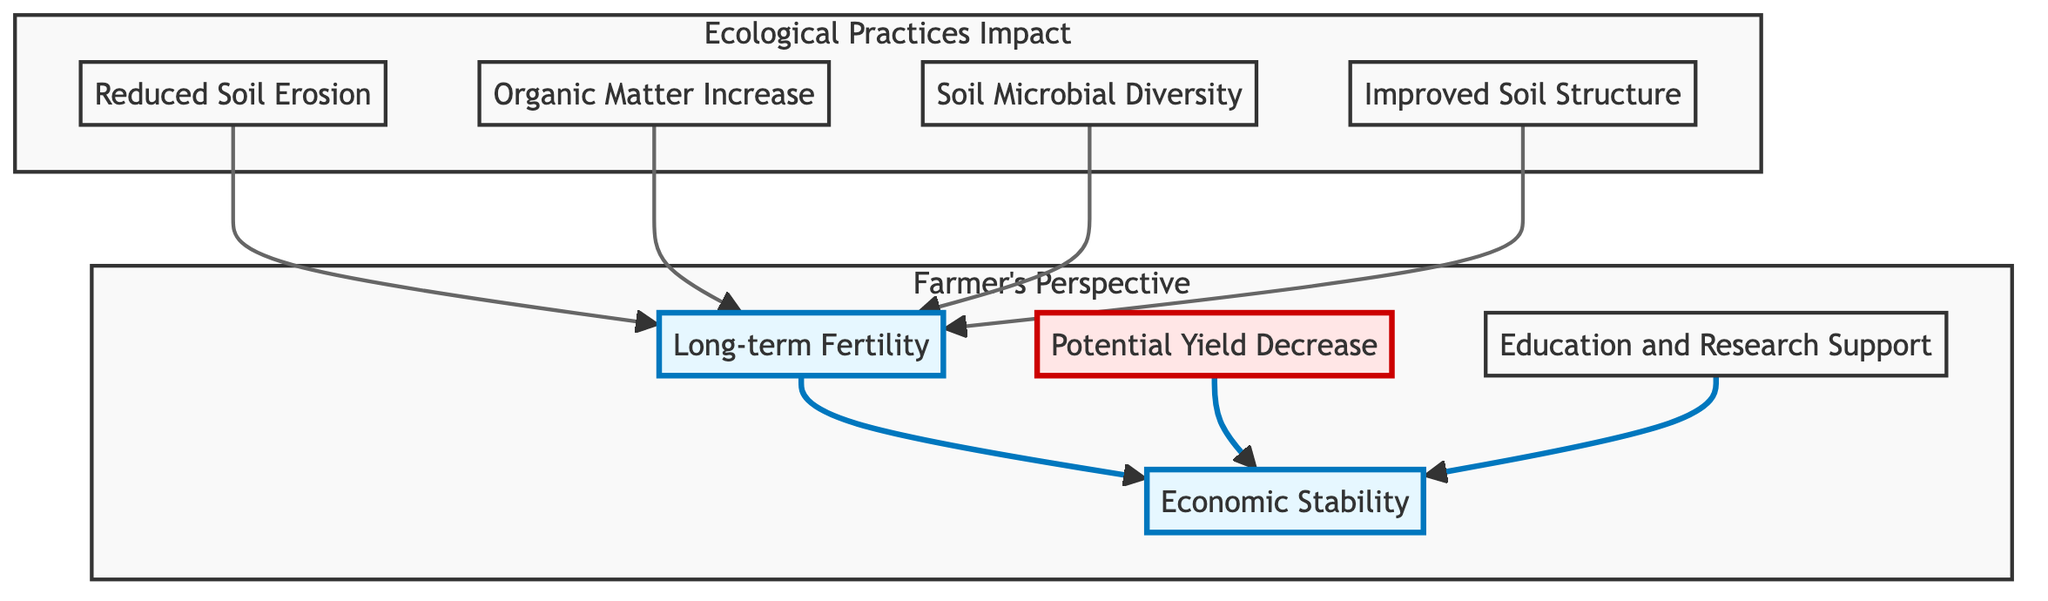What is the first node listed in the diagram? The first node listed in the diagram is "Reduced Soil Erosion". This can be identified as it is the first element in the list of nodes appearing in the flowchart.
Answer: Reduced Soil Erosion How many nodes are shown in the diagram? The diagram contains a total of 8 nodes, which can be counted by observing the distinct elements represented in the flowchart.
Answer: 8 What impact do improved soil structure practices have on long-term fertility? Improved soil structure enhances long-term fertility, as indicated by the arrows connecting "Improved Soil Structure" to "Long-term Fertility", showing that practices contribute positively to fertility over time.
Answer: Positive impact What node is directly linked to both "Long-term Fertility" and "Economic Stability"? "Long-term Fertility" is directly linked to "Economic Stability". The diagram shows a direct connection between these two nodes, indicating that fertility contributes to economic outcomes.
Answer: Long-term Fertility What is the potential downside mentioned in the diagram regarding ecological practices? The potential downside indicated in the diagram is "Potential Yield Decrease". This node suggests that adopting ecological practices might lead to a temporary reduction in crop yields.
Answer: Potential Yield Decrease How does soil microbial diversity affect long-term fertility? Soil microbial diversity promotes long-term fertility as it is shown in the diagram that "Soil Microbial Diversity" feeds into "Long-term Fertility". This indicates that higher microbial diversity contributes positively to sustained soil fertility.
Answer: Promotes fertility Which node is classified under "Farmer's Perspective"? "Economic Stability" is classified under "Farmer's Perspective". This can be determined by observing the subgraph that includes this node, which emphasizes the relevance of ecological practices to a farmer's income stability.
Answer: Economic Stability What practices can lead to reduced soil erosion according to the diagram? The diagram lists "cover crops" and "crop rotations" as the practices that lead to reduced soil erosion, as indicated in the description of the "Reduced Soil Erosion" node.
Answer: Cover crops and crop rotations What is the relationship between education and research support with economic stability? Education and research support lead to economic stability, as indicated by the flow from "Education and Research Support" to "Economic Stability", suggesting that increased knowledge fosters a stable economic environment for farmers.
Answer: Leads to economic stability 